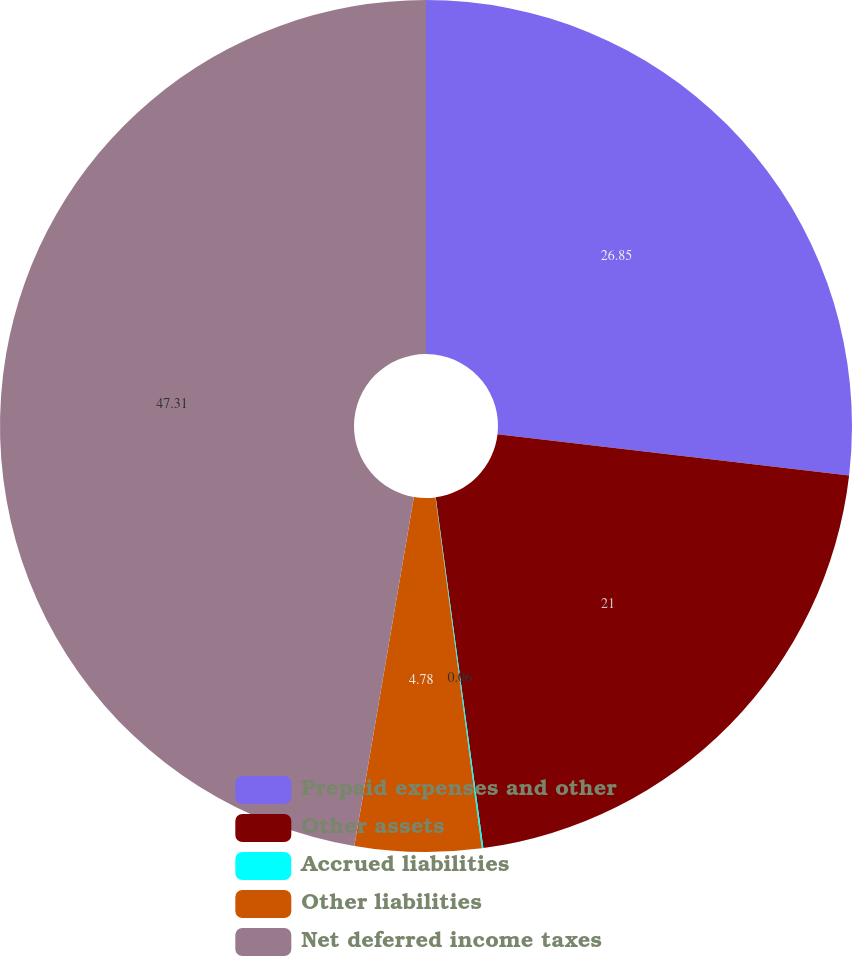Convert chart. <chart><loc_0><loc_0><loc_500><loc_500><pie_chart><fcel>Prepaid expenses and other<fcel>Other assets<fcel>Accrued liabilities<fcel>Other liabilities<fcel>Net deferred income taxes<nl><fcel>26.85%<fcel>21.0%<fcel>0.06%<fcel>4.78%<fcel>47.31%<nl></chart> 